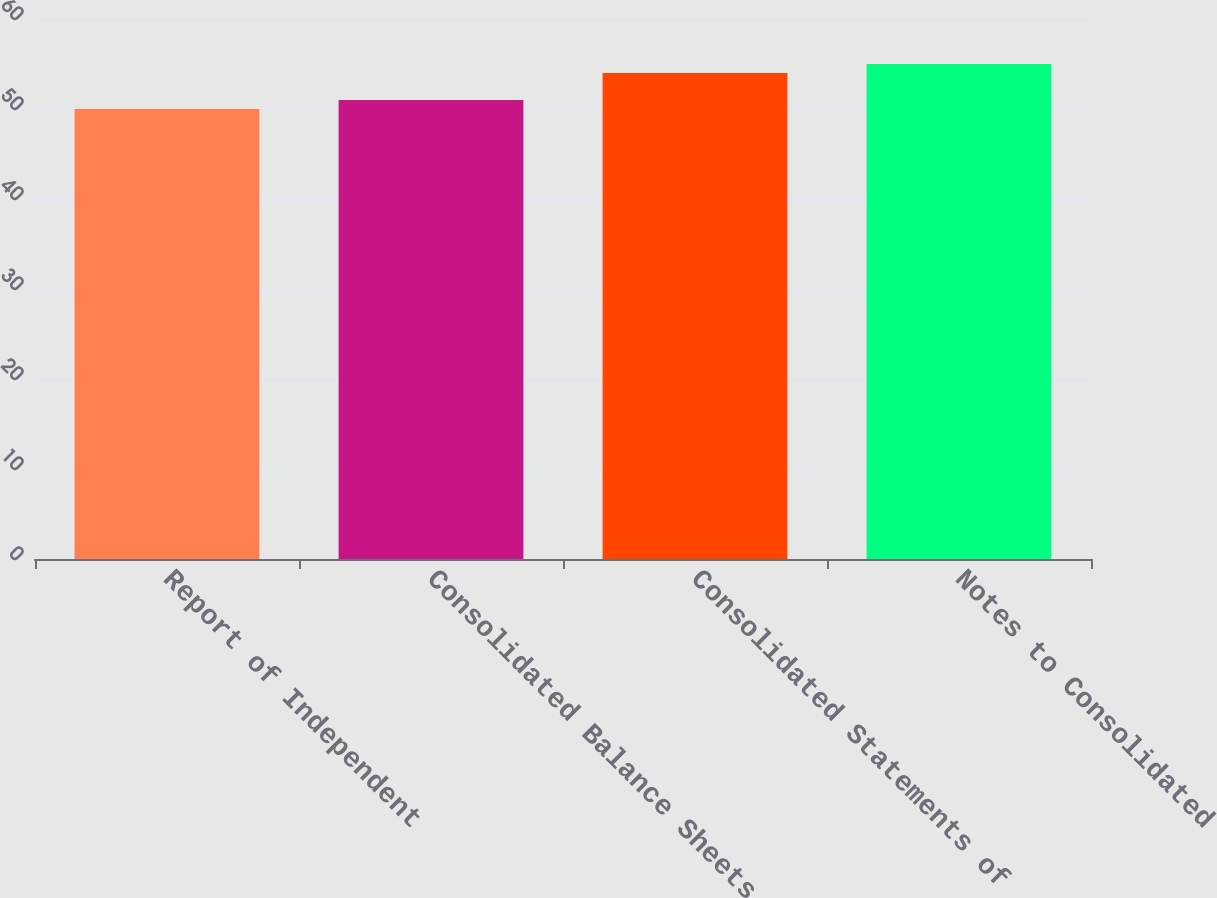Convert chart. <chart><loc_0><loc_0><loc_500><loc_500><bar_chart><fcel>Report of Independent<fcel>Consolidated Balance Sheets<fcel>Consolidated Statements of<fcel>Notes to Consolidated<nl><fcel>50<fcel>51<fcel>54<fcel>55<nl></chart> 